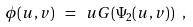Convert formula to latex. <formula><loc_0><loc_0><loc_500><loc_500>\phi ( u , v ) \ = \ u G ( \Psi _ { 2 } ( u , v ) ) \ ,</formula> 